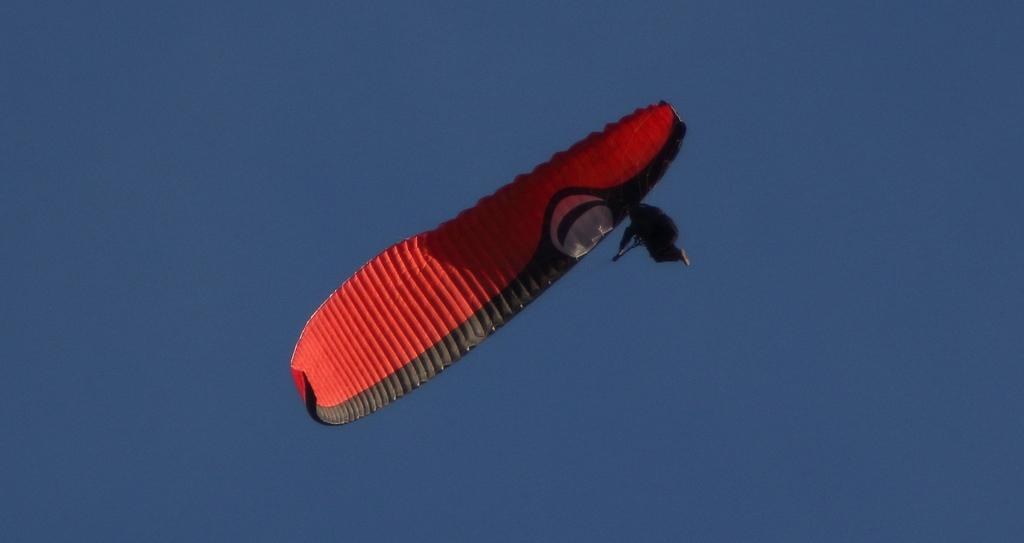What is the main subject of the image? There is a person in the image. What is the person doing in the image? The person is flying in the sky. How is the person flying in the sky? The person is using a parachute. What colors are visible on the parachute? The parachute is red and black in color. Where is the spring located in the image? There is no spring present in the image. What type of mark can be seen on the person's parachute? There is no mark visible on the person's parachute in the image. 